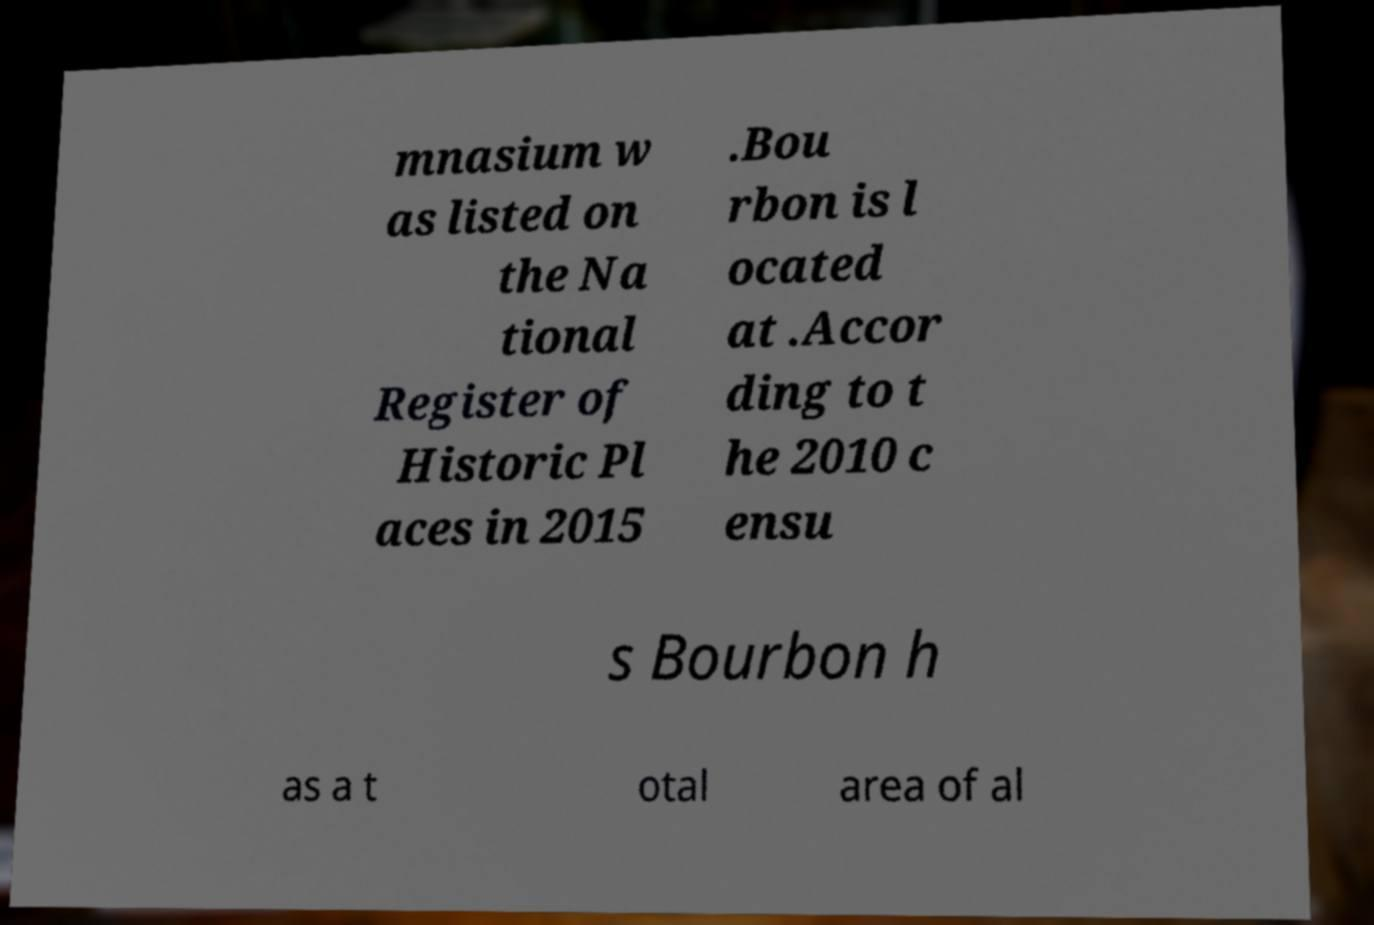Can you accurately transcribe the text from the provided image for me? mnasium w as listed on the Na tional Register of Historic Pl aces in 2015 .Bou rbon is l ocated at .Accor ding to t he 2010 c ensu s Bourbon h as a t otal area of al 